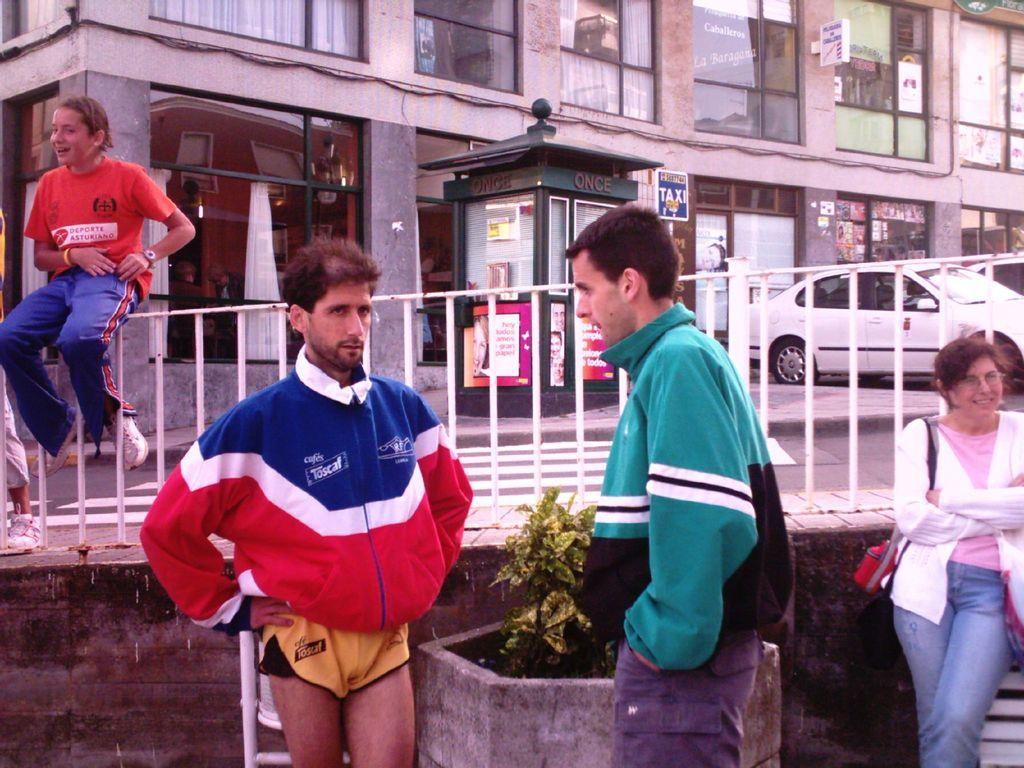<image>
Summarize the visual content of the image. A man wearing a red white and blue jacket with a Toscaf logo printed on front. 